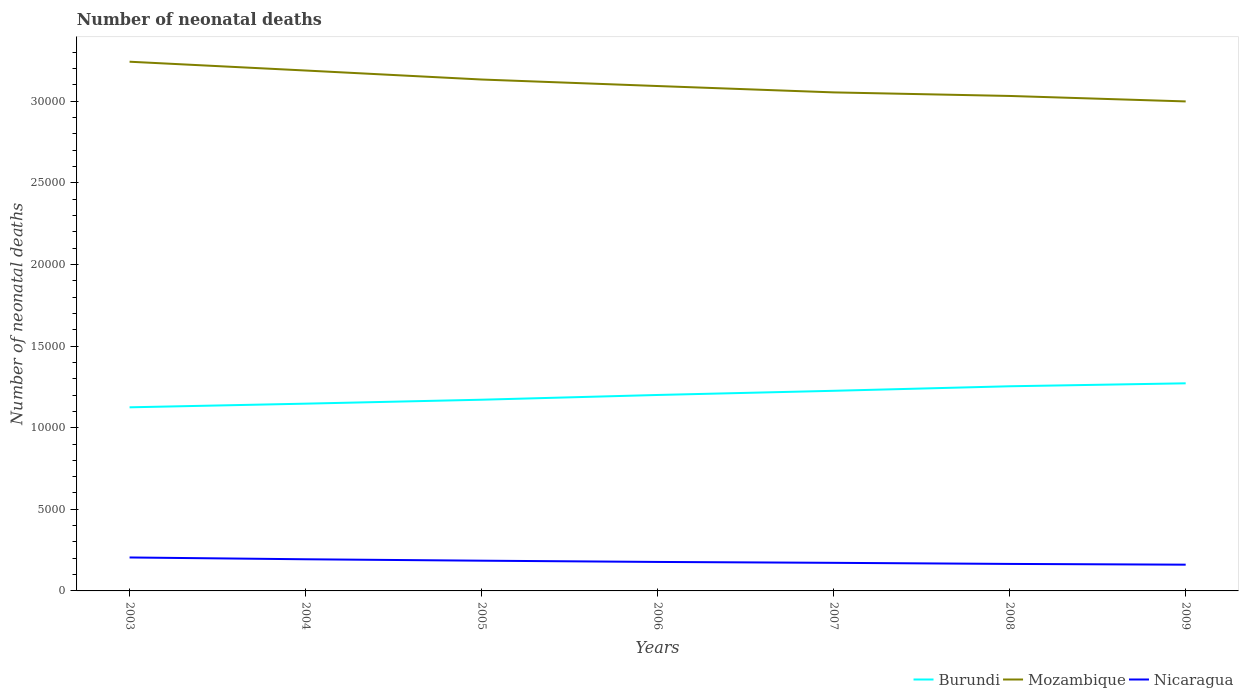Does the line corresponding to Nicaragua intersect with the line corresponding to Burundi?
Ensure brevity in your answer.  No. Across all years, what is the maximum number of neonatal deaths in in Nicaragua?
Keep it short and to the point. 1608. In which year was the number of neonatal deaths in in Mozambique maximum?
Keep it short and to the point. 2009. What is the total number of neonatal deaths in in Mozambique in the graph?
Offer a terse response. 218. What is the difference between the highest and the second highest number of neonatal deaths in in Nicaragua?
Provide a succinct answer. 442. Is the number of neonatal deaths in in Nicaragua strictly greater than the number of neonatal deaths in in Burundi over the years?
Ensure brevity in your answer.  Yes. How many lines are there?
Offer a very short reply. 3. Are the values on the major ticks of Y-axis written in scientific E-notation?
Ensure brevity in your answer.  No. Does the graph contain any zero values?
Your response must be concise. No. Does the graph contain grids?
Your answer should be compact. No. Where does the legend appear in the graph?
Ensure brevity in your answer.  Bottom right. How many legend labels are there?
Give a very brief answer. 3. How are the legend labels stacked?
Ensure brevity in your answer.  Horizontal. What is the title of the graph?
Give a very brief answer. Number of neonatal deaths. What is the label or title of the Y-axis?
Make the answer very short. Number of neonatal deaths. What is the Number of neonatal deaths in Burundi in 2003?
Your answer should be compact. 1.12e+04. What is the Number of neonatal deaths of Mozambique in 2003?
Provide a short and direct response. 3.24e+04. What is the Number of neonatal deaths in Nicaragua in 2003?
Make the answer very short. 2050. What is the Number of neonatal deaths in Burundi in 2004?
Your answer should be very brief. 1.15e+04. What is the Number of neonatal deaths of Mozambique in 2004?
Ensure brevity in your answer.  3.19e+04. What is the Number of neonatal deaths in Nicaragua in 2004?
Your answer should be very brief. 1939. What is the Number of neonatal deaths in Burundi in 2005?
Your answer should be compact. 1.17e+04. What is the Number of neonatal deaths of Mozambique in 2005?
Give a very brief answer. 3.13e+04. What is the Number of neonatal deaths in Nicaragua in 2005?
Ensure brevity in your answer.  1852. What is the Number of neonatal deaths of Burundi in 2006?
Keep it short and to the point. 1.20e+04. What is the Number of neonatal deaths of Mozambique in 2006?
Offer a terse response. 3.09e+04. What is the Number of neonatal deaths of Nicaragua in 2006?
Provide a succinct answer. 1776. What is the Number of neonatal deaths in Burundi in 2007?
Provide a succinct answer. 1.23e+04. What is the Number of neonatal deaths in Mozambique in 2007?
Provide a succinct answer. 3.05e+04. What is the Number of neonatal deaths in Nicaragua in 2007?
Provide a succinct answer. 1721. What is the Number of neonatal deaths in Burundi in 2008?
Provide a succinct answer. 1.25e+04. What is the Number of neonatal deaths in Mozambique in 2008?
Ensure brevity in your answer.  3.03e+04. What is the Number of neonatal deaths of Nicaragua in 2008?
Offer a terse response. 1654. What is the Number of neonatal deaths of Burundi in 2009?
Make the answer very short. 1.27e+04. What is the Number of neonatal deaths of Mozambique in 2009?
Your answer should be compact. 3.00e+04. What is the Number of neonatal deaths of Nicaragua in 2009?
Provide a succinct answer. 1608. Across all years, what is the maximum Number of neonatal deaths in Burundi?
Make the answer very short. 1.27e+04. Across all years, what is the maximum Number of neonatal deaths of Mozambique?
Your answer should be very brief. 3.24e+04. Across all years, what is the maximum Number of neonatal deaths in Nicaragua?
Provide a short and direct response. 2050. Across all years, what is the minimum Number of neonatal deaths in Burundi?
Provide a succinct answer. 1.12e+04. Across all years, what is the minimum Number of neonatal deaths in Mozambique?
Give a very brief answer. 3.00e+04. Across all years, what is the minimum Number of neonatal deaths of Nicaragua?
Provide a succinct answer. 1608. What is the total Number of neonatal deaths in Burundi in the graph?
Your answer should be very brief. 8.40e+04. What is the total Number of neonatal deaths of Mozambique in the graph?
Provide a succinct answer. 2.17e+05. What is the total Number of neonatal deaths in Nicaragua in the graph?
Your response must be concise. 1.26e+04. What is the difference between the Number of neonatal deaths in Burundi in 2003 and that in 2004?
Your answer should be compact. -224. What is the difference between the Number of neonatal deaths in Mozambique in 2003 and that in 2004?
Give a very brief answer. 539. What is the difference between the Number of neonatal deaths of Nicaragua in 2003 and that in 2004?
Your answer should be very brief. 111. What is the difference between the Number of neonatal deaths of Burundi in 2003 and that in 2005?
Your answer should be very brief. -466. What is the difference between the Number of neonatal deaths in Mozambique in 2003 and that in 2005?
Provide a succinct answer. 1090. What is the difference between the Number of neonatal deaths in Nicaragua in 2003 and that in 2005?
Your answer should be compact. 198. What is the difference between the Number of neonatal deaths in Burundi in 2003 and that in 2006?
Your answer should be very brief. -757. What is the difference between the Number of neonatal deaths of Mozambique in 2003 and that in 2006?
Your response must be concise. 1489. What is the difference between the Number of neonatal deaths of Nicaragua in 2003 and that in 2006?
Offer a very short reply. 274. What is the difference between the Number of neonatal deaths of Burundi in 2003 and that in 2007?
Keep it short and to the point. -1012. What is the difference between the Number of neonatal deaths in Mozambique in 2003 and that in 2007?
Provide a succinct answer. 1879. What is the difference between the Number of neonatal deaths of Nicaragua in 2003 and that in 2007?
Ensure brevity in your answer.  329. What is the difference between the Number of neonatal deaths of Burundi in 2003 and that in 2008?
Give a very brief answer. -1290. What is the difference between the Number of neonatal deaths of Mozambique in 2003 and that in 2008?
Your answer should be compact. 2097. What is the difference between the Number of neonatal deaths in Nicaragua in 2003 and that in 2008?
Your response must be concise. 396. What is the difference between the Number of neonatal deaths of Burundi in 2003 and that in 2009?
Offer a very short reply. -1471. What is the difference between the Number of neonatal deaths of Mozambique in 2003 and that in 2009?
Your response must be concise. 2432. What is the difference between the Number of neonatal deaths of Nicaragua in 2003 and that in 2009?
Give a very brief answer. 442. What is the difference between the Number of neonatal deaths in Burundi in 2004 and that in 2005?
Give a very brief answer. -242. What is the difference between the Number of neonatal deaths in Mozambique in 2004 and that in 2005?
Keep it short and to the point. 551. What is the difference between the Number of neonatal deaths in Burundi in 2004 and that in 2006?
Your response must be concise. -533. What is the difference between the Number of neonatal deaths in Mozambique in 2004 and that in 2006?
Provide a short and direct response. 950. What is the difference between the Number of neonatal deaths of Nicaragua in 2004 and that in 2006?
Offer a terse response. 163. What is the difference between the Number of neonatal deaths of Burundi in 2004 and that in 2007?
Ensure brevity in your answer.  -788. What is the difference between the Number of neonatal deaths in Mozambique in 2004 and that in 2007?
Keep it short and to the point. 1340. What is the difference between the Number of neonatal deaths of Nicaragua in 2004 and that in 2007?
Ensure brevity in your answer.  218. What is the difference between the Number of neonatal deaths in Burundi in 2004 and that in 2008?
Ensure brevity in your answer.  -1066. What is the difference between the Number of neonatal deaths of Mozambique in 2004 and that in 2008?
Give a very brief answer. 1558. What is the difference between the Number of neonatal deaths in Nicaragua in 2004 and that in 2008?
Ensure brevity in your answer.  285. What is the difference between the Number of neonatal deaths of Burundi in 2004 and that in 2009?
Give a very brief answer. -1247. What is the difference between the Number of neonatal deaths in Mozambique in 2004 and that in 2009?
Give a very brief answer. 1893. What is the difference between the Number of neonatal deaths in Nicaragua in 2004 and that in 2009?
Offer a very short reply. 331. What is the difference between the Number of neonatal deaths in Burundi in 2005 and that in 2006?
Offer a very short reply. -291. What is the difference between the Number of neonatal deaths in Mozambique in 2005 and that in 2006?
Your answer should be very brief. 399. What is the difference between the Number of neonatal deaths of Nicaragua in 2005 and that in 2006?
Offer a very short reply. 76. What is the difference between the Number of neonatal deaths in Burundi in 2005 and that in 2007?
Your answer should be compact. -546. What is the difference between the Number of neonatal deaths in Mozambique in 2005 and that in 2007?
Ensure brevity in your answer.  789. What is the difference between the Number of neonatal deaths of Nicaragua in 2005 and that in 2007?
Offer a very short reply. 131. What is the difference between the Number of neonatal deaths in Burundi in 2005 and that in 2008?
Keep it short and to the point. -824. What is the difference between the Number of neonatal deaths of Mozambique in 2005 and that in 2008?
Your answer should be compact. 1007. What is the difference between the Number of neonatal deaths in Nicaragua in 2005 and that in 2008?
Give a very brief answer. 198. What is the difference between the Number of neonatal deaths of Burundi in 2005 and that in 2009?
Provide a succinct answer. -1005. What is the difference between the Number of neonatal deaths of Mozambique in 2005 and that in 2009?
Provide a succinct answer. 1342. What is the difference between the Number of neonatal deaths of Nicaragua in 2005 and that in 2009?
Your answer should be very brief. 244. What is the difference between the Number of neonatal deaths in Burundi in 2006 and that in 2007?
Make the answer very short. -255. What is the difference between the Number of neonatal deaths of Mozambique in 2006 and that in 2007?
Keep it short and to the point. 390. What is the difference between the Number of neonatal deaths in Burundi in 2006 and that in 2008?
Offer a terse response. -533. What is the difference between the Number of neonatal deaths of Mozambique in 2006 and that in 2008?
Keep it short and to the point. 608. What is the difference between the Number of neonatal deaths in Nicaragua in 2006 and that in 2008?
Keep it short and to the point. 122. What is the difference between the Number of neonatal deaths of Burundi in 2006 and that in 2009?
Offer a terse response. -714. What is the difference between the Number of neonatal deaths in Mozambique in 2006 and that in 2009?
Keep it short and to the point. 943. What is the difference between the Number of neonatal deaths in Nicaragua in 2006 and that in 2009?
Ensure brevity in your answer.  168. What is the difference between the Number of neonatal deaths in Burundi in 2007 and that in 2008?
Give a very brief answer. -278. What is the difference between the Number of neonatal deaths in Mozambique in 2007 and that in 2008?
Give a very brief answer. 218. What is the difference between the Number of neonatal deaths in Burundi in 2007 and that in 2009?
Give a very brief answer. -459. What is the difference between the Number of neonatal deaths of Mozambique in 2007 and that in 2009?
Make the answer very short. 553. What is the difference between the Number of neonatal deaths of Nicaragua in 2007 and that in 2009?
Provide a short and direct response. 113. What is the difference between the Number of neonatal deaths of Burundi in 2008 and that in 2009?
Make the answer very short. -181. What is the difference between the Number of neonatal deaths in Mozambique in 2008 and that in 2009?
Give a very brief answer. 335. What is the difference between the Number of neonatal deaths in Burundi in 2003 and the Number of neonatal deaths in Mozambique in 2004?
Your response must be concise. -2.06e+04. What is the difference between the Number of neonatal deaths of Burundi in 2003 and the Number of neonatal deaths of Nicaragua in 2004?
Give a very brief answer. 9310. What is the difference between the Number of neonatal deaths in Mozambique in 2003 and the Number of neonatal deaths in Nicaragua in 2004?
Your response must be concise. 3.05e+04. What is the difference between the Number of neonatal deaths in Burundi in 2003 and the Number of neonatal deaths in Mozambique in 2005?
Keep it short and to the point. -2.01e+04. What is the difference between the Number of neonatal deaths in Burundi in 2003 and the Number of neonatal deaths in Nicaragua in 2005?
Give a very brief answer. 9397. What is the difference between the Number of neonatal deaths of Mozambique in 2003 and the Number of neonatal deaths of Nicaragua in 2005?
Offer a very short reply. 3.06e+04. What is the difference between the Number of neonatal deaths of Burundi in 2003 and the Number of neonatal deaths of Mozambique in 2006?
Your answer should be very brief. -1.97e+04. What is the difference between the Number of neonatal deaths in Burundi in 2003 and the Number of neonatal deaths in Nicaragua in 2006?
Make the answer very short. 9473. What is the difference between the Number of neonatal deaths in Mozambique in 2003 and the Number of neonatal deaths in Nicaragua in 2006?
Keep it short and to the point. 3.06e+04. What is the difference between the Number of neonatal deaths in Burundi in 2003 and the Number of neonatal deaths in Mozambique in 2007?
Make the answer very short. -1.93e+04. What is the difference between the Number of neonatal deaths in Burundi in 2003 and the Number of neonatal deaths in Nicaragua in 2007?
Your response must be concise. 9528. What is the difference between the Number of neonatal deaths in Mozambique in 2003 and the Number of neonatal deaths in Nicaragua in 2007?
Provide a succinct answer. 3.07e+04. What is the difference between the Number of neonatal deaths in Burundi in 2003 and the Number of neonatal deaths in Mozambique in 2008?
Ensure brevity in your answer.  -1.91e+04. What is the difference between the Number of neonatal deaths of Burundi in 2003 and the Number of neonatal deaths of Nicaragua in 2008?
Give a very brief answer. 9595. What is the difference between the Number of neonatal deaths in Mozambique in 2003 and the Number of neonatal deaths in Nicaragua in 2008?
Keep it short and to the point. 3.08e+04. What is the difference between the Number of neonatal deaths in Burundi in 2003 and the Number of neonatal deaths in Mozambique in 2009?
Your response must be concise. -1.87e+04. What is the difference between the Number of neonatal deaths in Burundi in 2003 and the Number of neonatal deaths in Nicaragua in 2009?
Keep it short and to the point. 9641. What is the difference between the Number of neonatal deaths of Mozambique in 2003 and the Number of neonatal deaths of Nicaragua in 2009?
Offer a terse response. 3.08e+04. What is the difference between the Number of neonatal deaths in Burundi in 2004 and the Number of neonatal deaths in Mozambique in 2005?
Your answer should be very brief. -1.99e+04. What is the difference between the Number of neonatal deaths in Burundi in 2004 and the Number of neonatal deaths in Nicaragua in 2005?
Offer a very short reply. 9621. What is the difference between the Number of neonatal deaths in Mozambique in 2004 and the Number of neonatal deaths in Nicaragua in 2005?
Ensure brevity in your answer.  3.00e+04. What is the difference between the Number of neonatal deaths of Burundi in 2004 and the Number of neonatal deaths of Mozambique in 2006?
Ensure brevity in your answer.  -1.95e+04. What is the difference between the Number of neonatal deaths of Burundi in 2004 and the Number of neonatal deaths of Nicaragua in 2006?
Give a very brief answer. 9697. What is the difference between the Number of neonatal deaths in Mozambique in 2004 and the Number of neonatal deaths in Nicaragua in 2006?
Offer a terse response. 3.01e+04. What is the difference between the Number of neonatal deaths in Burundi in 2004 and the Number of neonatal deaths in Mozambique in 2007?
Make the answer very short. -1.91e+04. What is the difference between the Number of neonatal deaths of Burundi in 2004 and the Number of neonatal deaths of Nicaragua in 2007?
Provide a succinct answer. 9752. What is the difference between the Number of neonatal deaths in Mozambique in 2004 and the Number of neonatal deaths in Nicaragua in 2007?
Your answer should be compact. 3.02e+04. What is the difference between the Number of neonatal deaths in Burundi in 2004 and the Number of neonatal deaths in Mozambique in 2008?
Make the answer very short. -1.89e+04. What is the difference between the Number of neonatal deaths of Burundi in 2004 and the Number of neonatal deaths of Nicaragua in 2008?
Provide a succinct answer. 9819. What is the difference between the Number of neonatal deaths of Mozambique in 2004 and the Number of neonatal deaths of Nicaragua in 2008?
Ensure brevity in your answer.  3.02e+04. What is the difference between the Number of neonatal deaths of Burundi in 2004 and the Number of neonatal deaths of Mozambique in 2009?
Your answer should be compact. -1.85e+04. What is the difference between the Number of neonatal deaths of Burundi in 2004 and the Number of neonatal deaths of Nicaragua in 2009?
Make the answer very short. 9865. What is the difference between the Number of neonatal deaths of Mozambique in 2004 and the Number of neonatal deaths of Nicaragua in 2009?
Offer a very short reply. 3.03e+04. What is the difference between the Number of neonatal deaths in Burundi in 2005 and the Number of neonatal deaths in Mozambique in 2006?
Provide a succinct answer. -1.92e+04. What is the difference between the Number of neonatal deaths in Burundi in 2005 and the Number of neonatal deaths in Nicaragua in 2006?
Provide a short and direct response. 9939. What is the difference between the Number of neonatal deaths in Mozambique in 2005 and the Number of neonatal deaths in Nicaragua in 2006?
Offer a very short reply. 2.96e+04. What is the difference between the Number of neonatal deaths in Burundi in 2005 and the Number of neonatal deaths in Mozambique in 2007?
Offer a very short reply. -1.88e+04. What is the difference between the Number of neonatal deaths of Burundi in 2005 and the Number of neonatal deaths of Nicaragua in 2007?
Your response must be concise. 9994. What is the difference between the Number of neonatal deaths in Mozambique in 2005 and the Number of neonatal deaths in Nicaragua in 2007?
Provide a short and direct response. 2.96e+04. What is the difference between the Number of neonatal deaths of Burundi in 2005 and the Number of neonatal deaths of Mozambique in 2008?
Offer a very short reply. -1.86e+04. What is the difference between the Number of neonatal deaths of Burundi in 2005 and the Number of neonatal deaths of Nicaragua in 2008?
Your response must be concise. 1.01e+04. What is the difference between the Number of neonatal deaths in Mozambique in 2005 and the Number of neonatal deaths in Nicaragua in 2008?
Make the answer very short. 2.97e+04. What is the difference between the Number of neonatal deaths in Burundi in 2005 and the Number of neonatal deaths in Mozambique in 2009?
Your response must be concise. -1.83e+04. What is the difference between the Number of neonatal deaths of Burundi in 2005 and the Number of neonatal deaths of Nicaragua in 2009?
Offer a very short reply. 1.01e+04. What is the difference between the Number of neonatal deaths of Mozambique in 2005 and the Number of neonatal deaths of Nicaragua in 2009?
Your answer should be very brief. 2.97e+04. What is the difference between the Number of neonatal deaths of Burundi in 2006 and the Number of neonatal deaths of Mozambique in 2007?
Offer a terse response. -1.85e+04. What is the difference between the Number of neonatal deaths in Burundi in 2006 and the Number of neonatal deaths in Nicaragua in 2007?
Give a very brief answer. 1.03e+04. What is the difference between the Number of neonatal deaths in Mozambique in 2006 and the Number of neonatal deaths in Nicaragua in 2007?
Your response must be concise. 2.92e+04. What is the difference between the Number of neonatal deaths in Burundi in 2006 and the Number of neonatal deaths in Mozambique in 2008?
Your response must be concise. -1.83e+04. What is the difference between the Number of neonatal deaths of Burundi in 2006 and the Number of neonatal deaths of Nicaragua in 2008?
Offer a very short reply. 1.04e+04. What is the difference between the Number of neonatal deaths in Mozambique in 2006 and the Number of neonatal deaths in Nicaragua in 2008?
Offer a terse response. 2.93e+04. What is the difference between the Number of neonatal deaths of Burundi in 2006 and the Number of neonatal deaths of Mozambique in 2009?
Offer a terse response. -1.80e+04. What is the difference between the Number of neonatal deaths in Burundi in 2006 and the Number of neonatal deaths in Nicaragua in 2009?
Give a very brief answer. 1.04e+04. What is the difference between the Number of neonatal deaths of Mozambique in 2006 and the Number of neonatal deaths of Nicaragua in 2009?
Make the answer very short. 2.93e+04. What is the difference between the Number of neonatal deaths of Burundi in 2007 and the Number of neonatal deaths of Mozambique in 2008?
Provide a succinct answer. -1.81e+04. What is the difference between the Number of neonatal deaths of Burundi in 2007 and the Number of neonatal deaths of Nicaragua in 2008?
Offer a terse response. 1.06e+04. What is the difference between the Number of neonatal deaths of Mozambique in 2007 and the Number of neonatal deaths of Nicaragua in 2008?
Provide a succinct answer. 2.89e+04. What is the difference between the Number of neonatal deaths of Burundi in 2007 and the Number of neonatal deaths of Mozambique in 2009?
Provide a succinct answer. -1.77e+04. What is the difference between the Number of neonatal deaths in Burundi in 2007 and the Number of neonatal deaths in Nicaragua in 2009?
Your response must be concise. 1.07e+04. What is the difference between the Number of neonatal deaths in Mozambique in 2007 and the Number of neonatal deaths in Nicaragua in 2009?
Your answer should be very brief. 2.89e+04. What is the difference between the Number of neonatal deaths in Burundi in 2008 and the Number of neonatal deaths in Mozambique in 2009?
Offer a very short reply. -1.75e+04. What is the difference between the Number of neonatal deaths of Burundi in 2008 and the Number of neonatal deaths of Nicaragua in 2009?
Offer a very short reply. 1.09e+04. What is the difference between the Number of neonatal deaths in Mozambique in 2008 and the Number of neonatal deaths in Nicaragua in 2009?
Provide a succinct answer. 2.87e+04. What is the average Number of neonatal deaths of Burundi per year?
Provide a short and direct response. 1.20e+04. What is the average Number of neonatal deaths of Mozambique per year?
Offer a terse response. 3.11e+04. What is the average Number of neonatal deaths of Nicaragua per year?
Make the answer very short. 1800. In the year 2003, what is the difference between the Number of neonatal deaths of Burundi and Number of neonatal deaths of Mozambique?
Give a very brief answer. -2.12e+04. In the year 2003, what is the difference between the Number of neonatal deaths of Burundi and Number of neonatal deaths of Nicaragua?
Offer a very short reply. 9199. In the year 2003, what is the difference between the Number of neonatal deaths in Mozambique and Number of neonatal deaths in Nicaragua?
Keep it short and to the point. 3.04e+04. In the year 2004, what is the difference between the Number of neonatal deaths in Burundi and Number of neonatal deaths in Mozambique?
Your response must be concise. -2.04e+04. In the year 2004, what is the difference between the Number of neonatal deaths in Burundi and Number of neonatal deaths in Nicaragua?
Ensure brevity in your answer.  9534. In the year 2004, what is the difference between the Number of neonatal deaths of Mozambique and Number of neonatal deaths of Nicaragua?
Give a very brief answer. 2.99e+04. In the year 2005, what is the difference between the Number of neonatal deaths in Burundi and Number of neonatal deaths in Mozambique?
Keep it short and to the point. -1.96e+04. In the year 2005, what is the difference between the Number of neonatal deaths in Burundi and Number of neonatal deaths in Nicaragua?
Make the answer very short. 9863. In the year 2005, what is the difference between the Number of neonatal deaths in Mozambique and Number of neonatal deaths in Nicaragua?
Ensure brevity in your answer.  2.95e+04. In the year 2006, what is the difference between the Number of neonatal deaths of Burundi and Number of neonatal deaths of Mozambique?
Keep it short and to the point. -1.89e+04. In the year 2006, what is the difference between the Number of neonatal deaths in Burundi and Number of neonatal deaths in Nicaragua?
Offer a terse response. 1.02e+04. In the year 2006, what is the difference between the Number of neonatal deaths in Mozambique and Number of neonatal deaths in Nicaragua?
Your answer should be compact. 2.92e+04. In the year 2007, what is the difference between the Number of neonatal deaths of Burundi and Number of neonatal deaths of Mozambique?
Provide a short and direct response. -1.83e+04. In the year 2007, what is the difference between the Number of neonatal deaths of Burundi and Number of neonatal deaths of Nicaragua?
Your answer should be very brief. 1.05e+04. In the year 2007, what is the difference between the Number of neonatal deaths of Mozambique and Number of neonatal deaths of Nicaragua?
Your response must be concise. 2.88e+04. In the year 2008, what is the difference between the Number of neonatal deaths in Burundi and Number of neonatal deaths in Mozambique?
Ensure brevity in your answer.  -1.78e+04. In the year 2008, what is the difference between the Number of neonatal deaths in Burundi and Number of neonatal deaths in Nicaragua?
Your answer should be very brief. 1.09e+04. In the year 2008, what is the difference between the Number of neonatal deaths of Mozambique and Number of neonatal deaths of Nicaragua?
Offer a terse response. 2.87e+04. In the year 2009, what is the difference between the Number of neonatal deaths of Burundi and Number of neonatal deaths of Mozambique?
Provide a succinct answer. -1.73e+04. In the year 2009, what is the difference between the Number of neonatal deaths in Burundi and Number of neonatal deaths in Nicaragua?
Your answer should be very brief. 1.11e+04. In the year 2009, what is the difference between the Number of neonatal deaths of Mozambique and Number of neonatal deaths of Nicaragua?
Provide a succinct answer. 2.84e+04. What is the ratio of the Number of neonatal deaths in Burundi in 2003 to that in 2004?
Offer a very short reply. 0.98. What is the ratio of the Number of neonatal deaths of Mozambique in 2003 to that in 2004?
Make the answer very short. 1.02. What is the ratio of the Number of neonatal deaths in Nicaragua in 2003 to that in 2004?
Offer a terse response. 1.06. What is the ratio of the Number of neonatal deaths of Burundi in 2003 to that in 2005?
Provide a succinct answer. 0.96. What is the ratio of the Number of neonatal deaths of Mozambique in 2003 to that in 2005?
Offer a terse response. 1.03. What is the ratio of the Number of neonatal deaths in Nicaragua in 2003 to that in 2005?
Your answer should be very brief. 1.11. What is the ratio of the Number of neonatal deaths in Burundi in 2003 to that in 2006?
Provide a succinct answer. 0.94. What is the ratio of the Number of neonatal deaths of Mozambique in 2003 to that in 2006?
Your response must be concise. 1.05. What is the ratio of the Number of neonatal deaths in Nicaragua in 2003 to that in 2006?
Offer a terse response. 1.15. What is the ratio of the Number of neonatal deaths of Burundi in 2003 to that in 2007?
Your response must be concise. 0.92. What is the ratio of the Number of neonatal deaths of Mozambique in 2003 to that in 2007?
Provide a succinct answer. 1.06. What is the ratio of the Number of neonatal deaths of Nicaragua in 2003 to that in 2007?
Offer a very short reply. 1.19. What is the ratio of the Number of neonatal deaths of Burundi in 2003 to that in 2008?
Give a very brief answer. 0.9. What is the ratio of the Number of neonatal deaths of Mozambique in 2003 to that in 2008?
Keep it short and to the point. 1.07. What is the ratio of the Number of neonatal deaths in Nicaragua in 2003 to that in 2008?
Make the answer very short. 1.24. What is the ratio of the Number of neonatal deaths of Burundi in 2003 to that in 2009?
Provide a succinct answer. 0.88. What is the ratio of the Number of neonatal deaths of Mozambique in 2003 to that in 2009?
Your response must be concise. 1.08. What is the ratio of the Number of neonatal deaths of Nicaragua in 2003 to that in 2009?
Your response must be concise. 1.27. What is the ratio of the Number of neonatal deaths of Burundi in 2004 to that in 2005?
Give a very brief answer. 0.98. What is the ratio of the Number of neonatal deaths in Mozambique in 2004 to that in 2005?
Keep it short and to the point. 1.02. What is the ratio of the Number of neonatal deaths of Nicaragua in 2004 to that in 2005?
Offer a terse response. 1.05. What is the ratio of the Number of neonatal deaths in Burundi in 2004 to that in 2006?
Make the answer very short. 0.96. What is the ratio of the Number of neonatal deaths in Mozambique in 2004 to that in 2006?
Offer a terse response. 1.03. What is the ratio of the Number of neonatal deaths in Nicaragua in 2004 to that in 2006?
Your response must be concise. 1.09. What is the ratio of the Number of neonatal deaths of Burundi in 2004 to that in 2007?
Your answer should be compact. 0.94. What is the ratio of the Number of neonatal deaths of Mozambique in 2004 to that in 2007?
Offer a terse response. 1.04. What is the ratio of the Number of neonatal deaths of Nicaragua in 2004 to that in 2007?
Your answer should be compact. 1.13. What is the ratio of the Number of neonatal deaths in Burundi in 2004 to that in 2008?
Offer a terse response. 0.92. What is the ratio of the Number of neonatal deaths in Mozambique in 2004 to that in 2008?
Your answer should be compact. 1.05. What is the ratio of the Number of neonatal deaths of Nicaragua in 2004 to that in 2008?
Keep it short and to the point. 1.17. What is the ratio of the Number of neonatal deaths in Burundi in 2004 to that in 2009?
Your response must be concise. 0.9. What is the ratio of the Number of neonatal deaths of Mozambique in 2004 to that in 2009?
Your answer should be compact. 1.06. What is the ratio of the Number of neonatal deaths in Nicaragua in 2004 to that in 2009?
Offer a very short reply. 1.21. What is the ratio of the Number of neonatal deaths of Burundi in 2005 to that in 2006?
Provide a succinct answer. 0.98. What is the ratio of the Number of neonatal deaths in Mozambique in 2005 to that in 2006?
Provide a succinct answer. 1.01. What is the ratio of the Number of neonatal deaths of Nicaragua in 2005 to that in 2006?
Your answer should be compact. 1.04. What is the ratio of the Number of neonatal deaths in Burundi in 2005 to that in 2007?
Your response must be concise. 0.96. What is the ratio of the Number of neonatal deaths in Mozambique in 2005 to that in 2007?
Your response must be concise. 1.03. What is the ratio of the Number of neonatal deaths of Nicaragua in 2005 to that in 2007?
Your answer should be compact. 1.08. What is the ratio of the Number of neonatal deaths in Burundi in 2005 to that in 2008?
Your response must be concise. 0.93. What is the ratio of the Number of neonatal deaths in Mozambique in 2005 to that in 2008?
Keep it short and to the point. 1.03. What is the ratio of the Number of neonatal deaths in Nicaragua in 2005 to that in 2008?
Keep it short and to the point. 1.12. What is the ratio of the Number of neonatal deaths in Burundi in 2005 to that in 2009?
Offer a very short reply. 0.92. What is the ratio of the Number of neonatal deaths of Mozambique in 2005 to that in 2009?
Ensure brevity in your answer.  1.04. What is the ratio of the Number of neonatal deaths in Nicaragua in 2005 to that in 2009?
Provide a short and direct response. 1.15. What is the ratio of the Number of neonatal deaths in Burundi in 2006 to that in 2007?
Provide a short and direct response. 0.98. What is the ratio of the Number of neonatal deaths of Mozambique in 2006 to that in 2007?
Ensure brevity in your answer.  1.01. What is the ratio of the Number of neonatal deaths in Nicaragua in 2006 to that in 2007?
Your response must be concise. 1.03. What is the ratio of the Number of neonatal deaths of Burundi in 2006 to that in 2008?
Provide a short and direct response. 0.96. What is the ratio of the Number of neonatal deaths of Mozambique in 2006 to that in 2008?
Make the answer very short. 1.02. What is the ratio of the Number of neonatal deaths in Nicaragua in 2006 to that in 2008?
Give a very brief answer. 1.07. What is the ratio of the Number of neonatal deaths of Burundi in 2006 to that in 2009?
Your answer should be compact. 0.94. What is the ratio of the Number of neonatal deaths in Mozambique in 2006 to that in 2009?
Keep it short and to the point. 1.03. What is the ratio of the Number of neonatal deaths of Nicaragua in 2006 to that in 2009?
Your answer should be very brief. 1.1. What is the ratio of the Number of neonatal deaths in Burundi in 2007 to that in 2008?
Your answer should be very brief. 0.98. What is the ratio of the Number of neonatal deaths in Mozambique in 2007 to that in 2008?
Ensure brevity in your answer.  1.01. What is the ratio of the Number of neonatal deaths in Nicaragua in 2007 to that in 2008?
Keep it short and to the point. 1.04. What is the ratio of the Number of neonatal deaths in Burundi in 2007 to that in 2009?
Your answer should be very brief. 0.96. What is the ratio of the Number of neonatal deaths of Mozambique in 2007 to that in 2009?
Offer a very short reply. 1.02. What is the ratio of the Number of neonatal deaths of Nicaragua in 2007 to that in 2009?
Your answer should be very brief. 1.07. What is the ratio of the Number of neonatal deaths of Burundi in 2008 to that in 2009?
Offer a terse response. 0.99. What is the ratio of the Number of neonatal deaths of Mozambique in 2008 to that in 2009?
Offer a terse response. 1.01. What is the ratio of the Number of neonatal deaths of Nicaragua in 2008 to that in 2009?
Ensure brevity in your answer.  1.03. What is the difference between the highest and the second highest Number of neonatal deaths in Burundi?
Your response must be concise. 181. What is the difference between the highest and the second highest Number of neonatal deaths of Mozambique?
Ensure brevity in your answer.  539. What is the difference between the highest and the second highest Number of neonatal deaths in Nicaragua?
Provide a succinct answer. 111. What is the difference between the highest and the lowest Number of neonatal deaths of Burundi?
Keep it short and to the point. 1471. What is the difference between the highest and the lowest Number of neonatal deaths in Mozambique?
Offer a very short reply. 2432. What is the difference between the highest and the lowest Number of neonatal deaths in Nicaragua?
Provide a succinct answer. 442. 